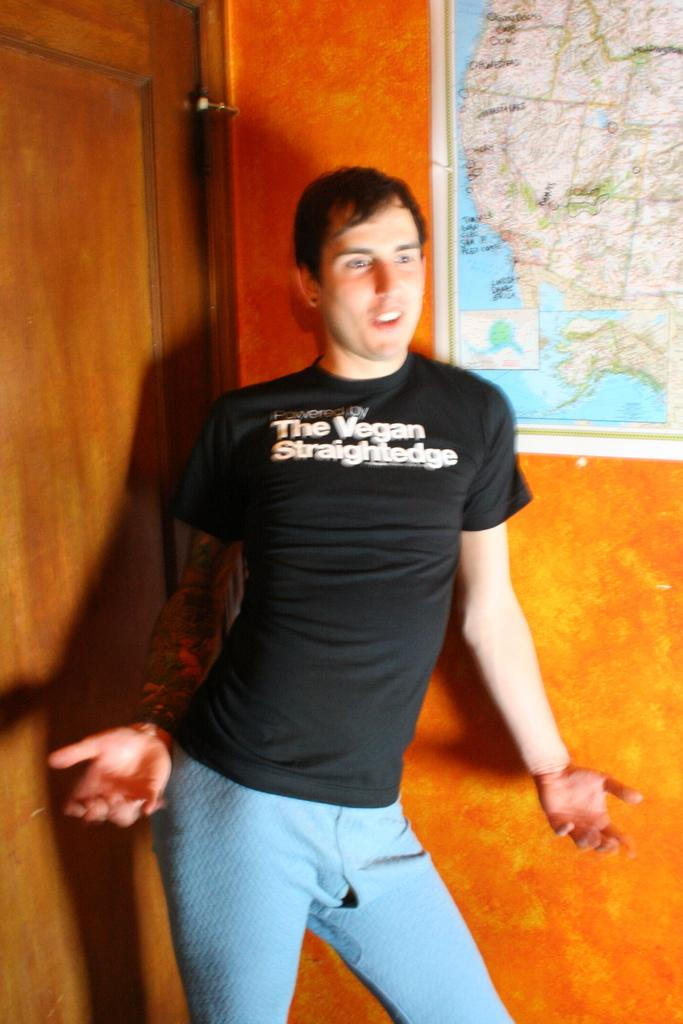<image>
Give a short and clear explanation of the subsequent image. a black shirt that says the word Vegan on it 